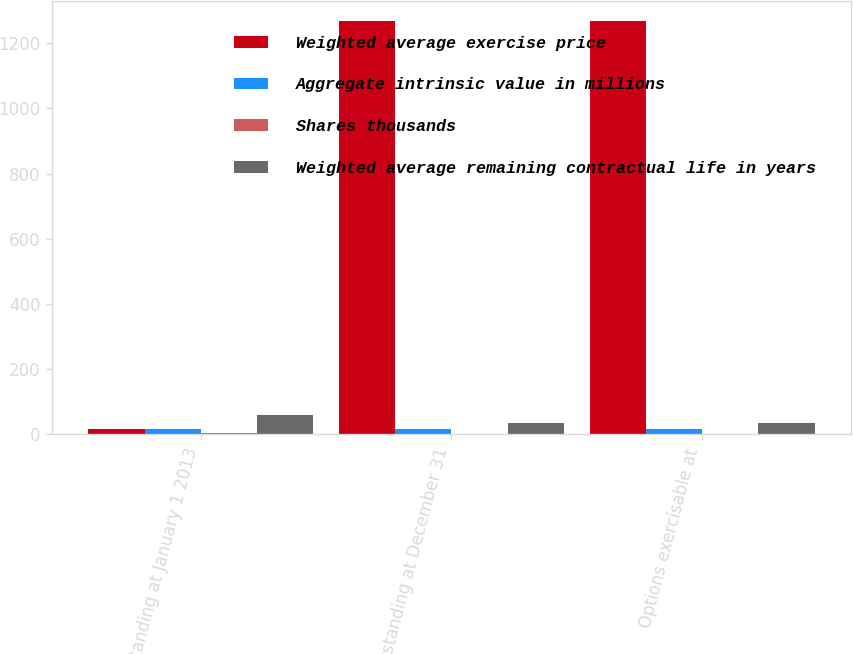<chart> <loc_0><loc_0><loc_500><loc_500><stacked_bar_chart><ecel><fcel>Outstanding at January 1 2013<fcel>Outstanding at December 31<fcel>Options exercisable at<nl><fcel>Weighted average exercise price<fcel>16.59<fcel>1267<fcel>1267<nl><fcel>Aggregate intrinsic value in millions<fcel>15.33<fcel>16.59<fcel>16.59<nl><fcel>Shares thousands<fcel>3.4<fcel>0.9<fcel>0.9<nl><fcel>Weighted average remaining contractual life in years<fcel>58.8<fcel>33.7<fcel>33.7<nl></chart> 